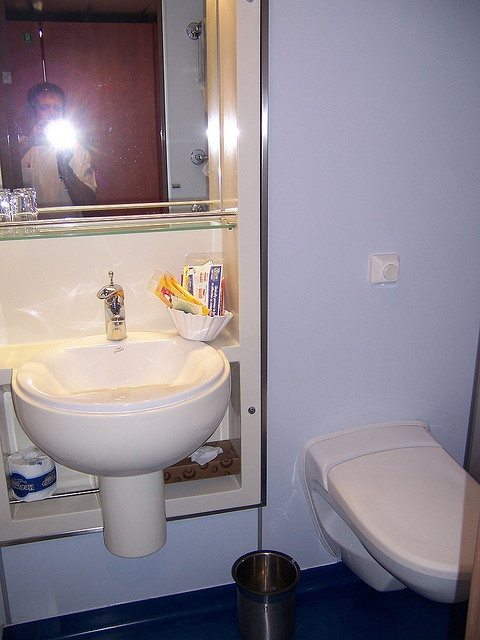Describe the objects in this image and their specific colors. I can see toilet in black, darkgray, and gray tones, sink in black, lightgray, tan, and darkgray tones, people in black, darkgray, gray, and lavender tones, bowl in black, lightgray, darkgray, and tan tones, and cup in black, darkgray, lightgray, and gray tones in this image. 